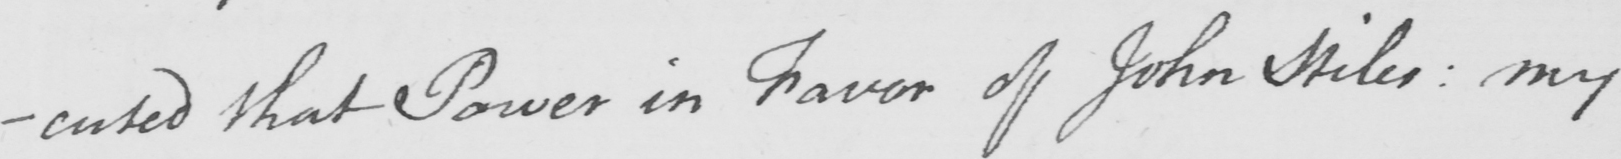What is written in this line of handwriting? ecuted that Power in Favor of John Miles :  my 